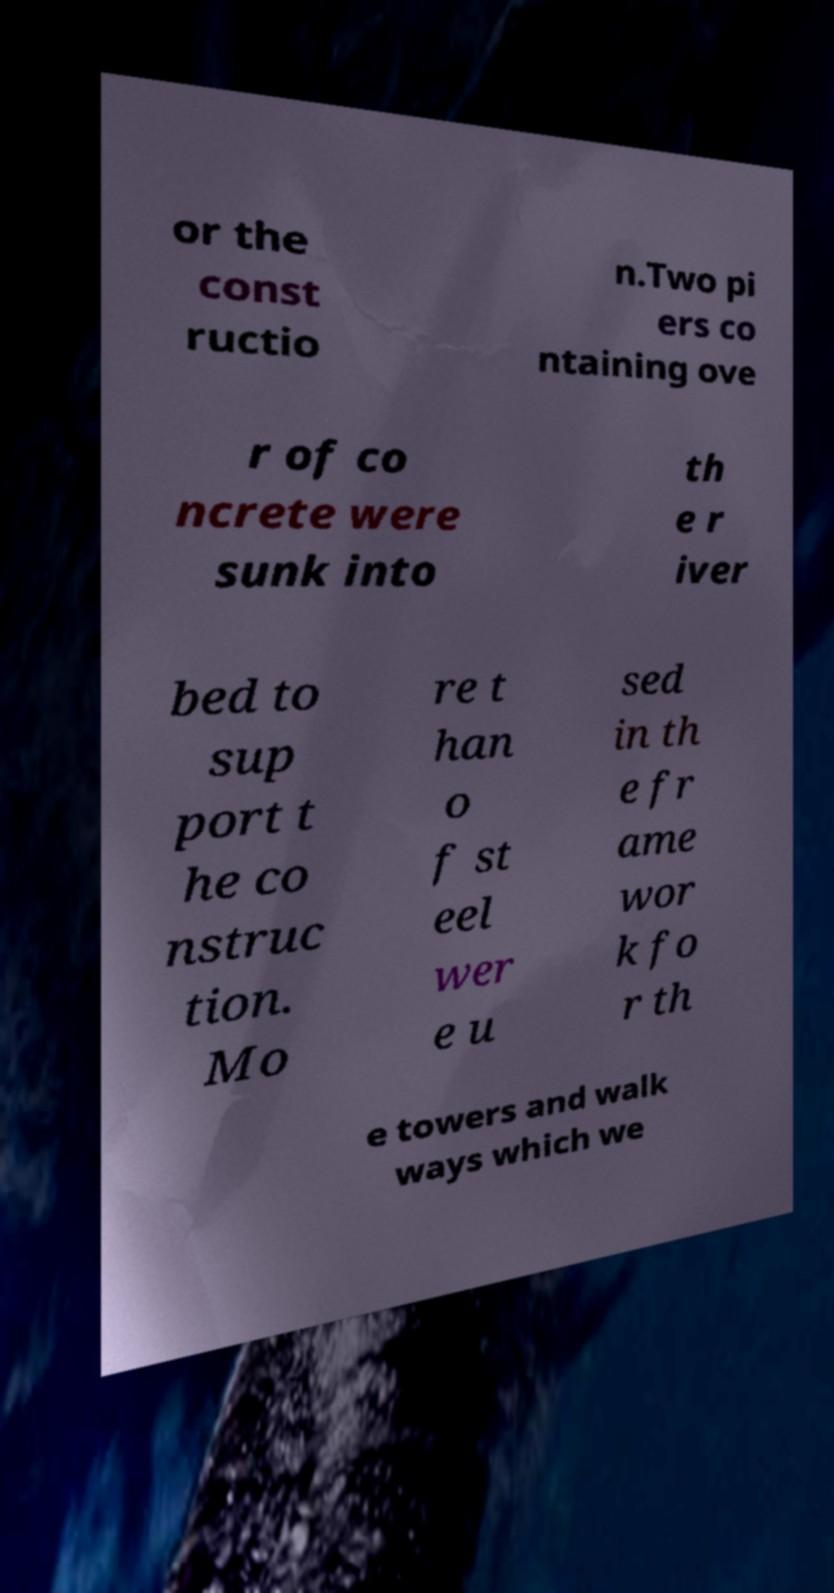Can you accurately transcribe the text from the provided image for me? or the const ructio n.Two pi ers co ntaining ove r of co ncrete were sunk into th e r iver bed to sup port t he co nstruc tion. Mo re t han o f st eel wer e u sed in th e fr ame wor k fo r th e towers and walk ways which we 